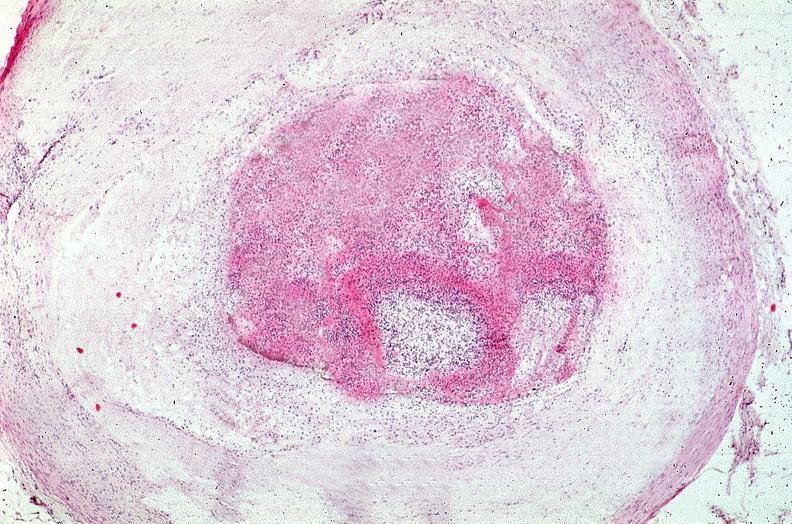s vasculature present?
Answer the question using a single word or phrase. Yes 